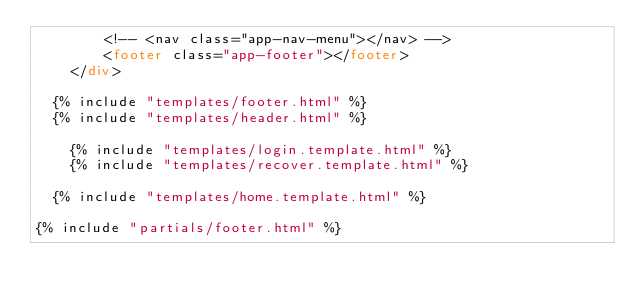Convert code to text. <code><loc_0><loc_0><loc_500><loc_500><_HTML_>        <!-- <nav class="app-nav-menu"></nav> -->
        <footer class="app-footer"></footer>
    </div>

	{% include "templates/footer.html" %}
	{% include "templates/header.html" %}
	
  	{% include "templates/login.template.html" %}
    {% include "templates/recover.template.html" %}

	{% include "templates/home.template.html" %}

{% include "partials/footer.html" %}</code> 